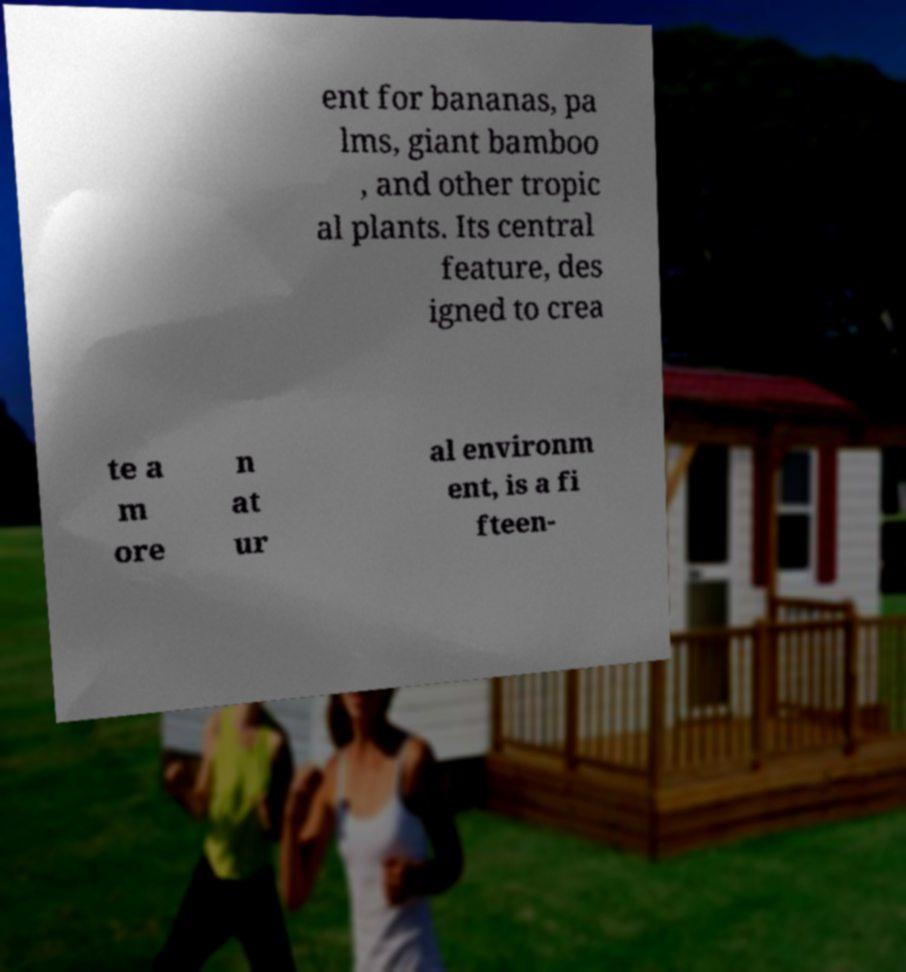Could you extract and type out the text from this image? ent for bananas, pa lms, giant bamboo , and other tropic al plants. Its central feature, des igned to crea te a m ore n at ur al environm ent, is a fi fteen- 